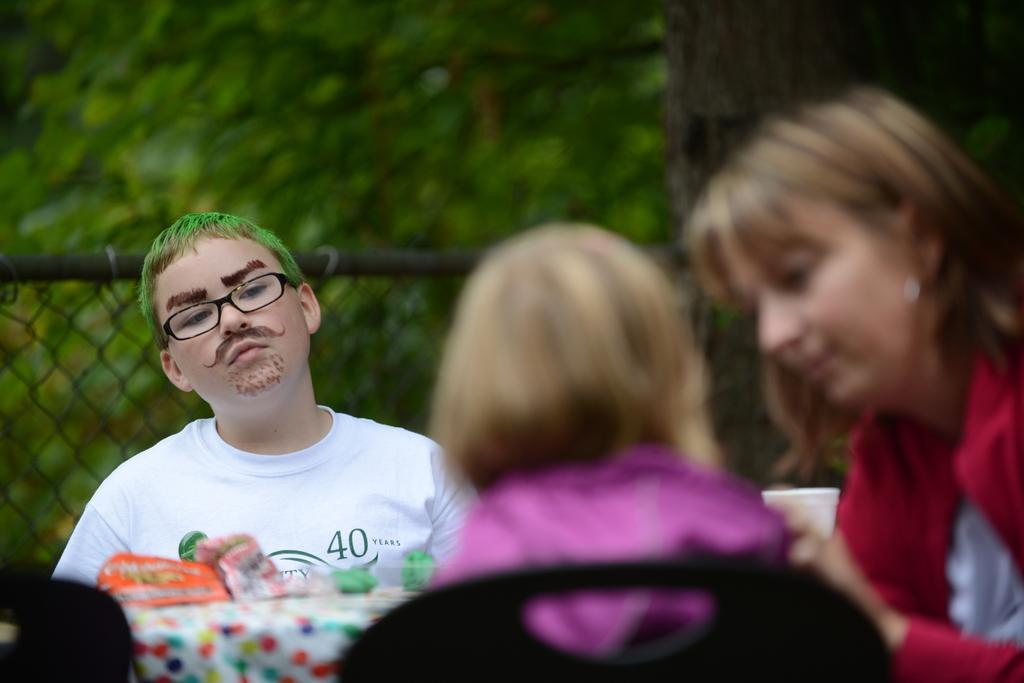Describe this image in one or two sentences. In this picture I can see a boy with spectacles, there are some objects on the table, there are chairs, there are two persons, there is wire fence, and in the background there are trees. 